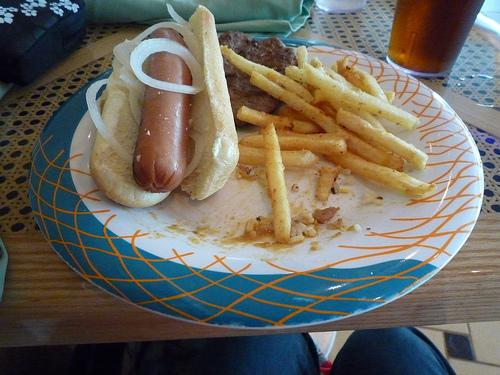Mention the assortment of food items and the beverage available in the image. The assortment includes a hot dog in a bun, seasoned french fries, a hamburger patty, and a drink in a plastic cup. Tell about the person's presence and the food elements on the plate. A person's knees wearing blue jeans are visible, and the plate has a hot dog, fries, and hamburger patty. Narrate the combination of food items and a beverage in the image. The image showcases a plate filled with a hot dog, french fries, a hamburger patty, and a beverage in a plastic cup. Describe the most prominent food item on the plate and its garnishing. A hot dog in a bun garnished with sliced white onions is the highlight on the plate. Characterize the hot dog in terms of the bread, filling, and seasoning. The hot dog is in a bun with a cooked hot dog and topped with white onions. Explain the scene in the image of the table with a plate containing various food items and accompanying elements. The image features a table set with a plate full of a hot dog, fries, a hamburger patty, a beverage, and a person's knees under the table. Comment on the focal point of the table setting in the image. The main attraction is a colorful plate filled with a hot dog, french fries, and a hamburger patty. Provide a concise account of the image, emphasizing the plate's components and the visible human element. A plate holds a hot dog with onions, french fries, and a hamburger patty, accompanied by a beverage, and a person's knees in blue jeans are visible. Enumerate the plate's contents and distinguish any additional accessories seen in the image. The plate has a hot dog, french fries, a hamburger patty, a beverage in a plastic cup, and a person's knees are visible. Give a brief description of the primary food items on the plate. The plate has a hot dog in a bun with onions, seasoned french fries, and a hamburger patty. 